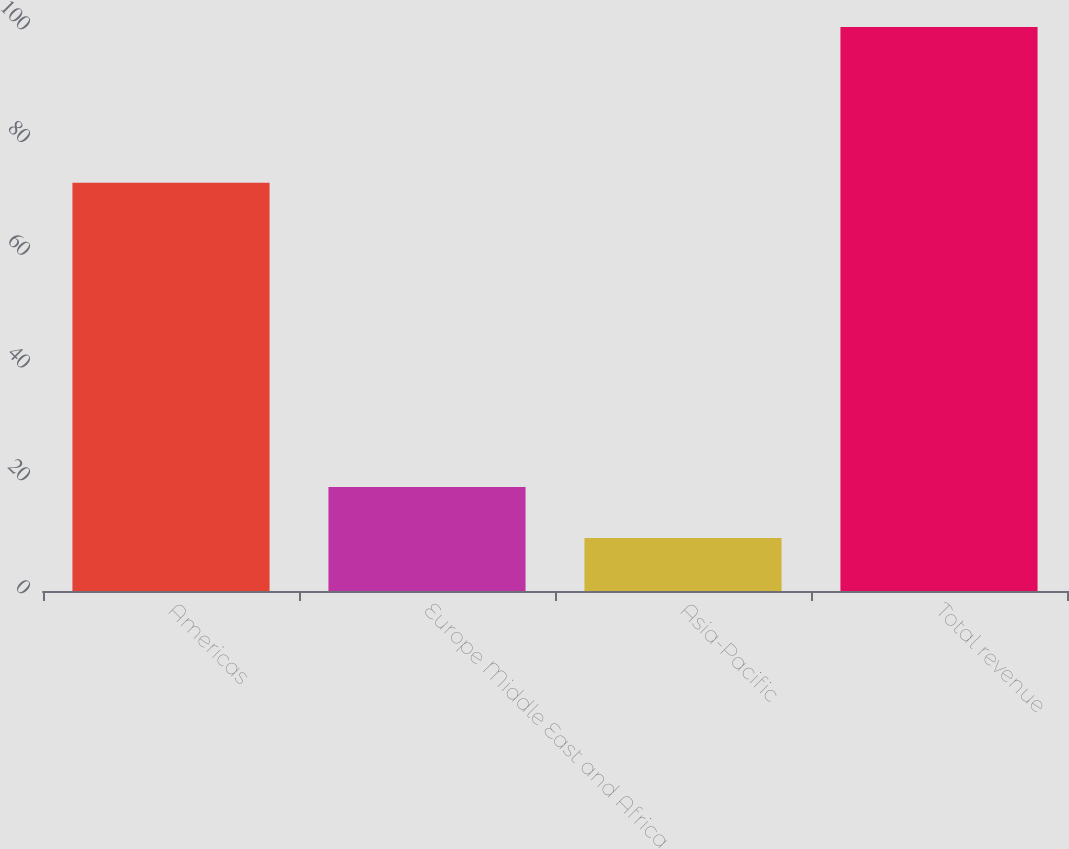Convert chart. <chart><loc_0><loc_0><loc_500><loc_500><bar_chart><fcel>Americas<fcel>Europe Middle East and Africa<fcel>Asia-Pacific<fcel>Total revenue<nl><fcel>72.4<fcel>18.46<fcel>9.4<fcel>100<nl></chart> 